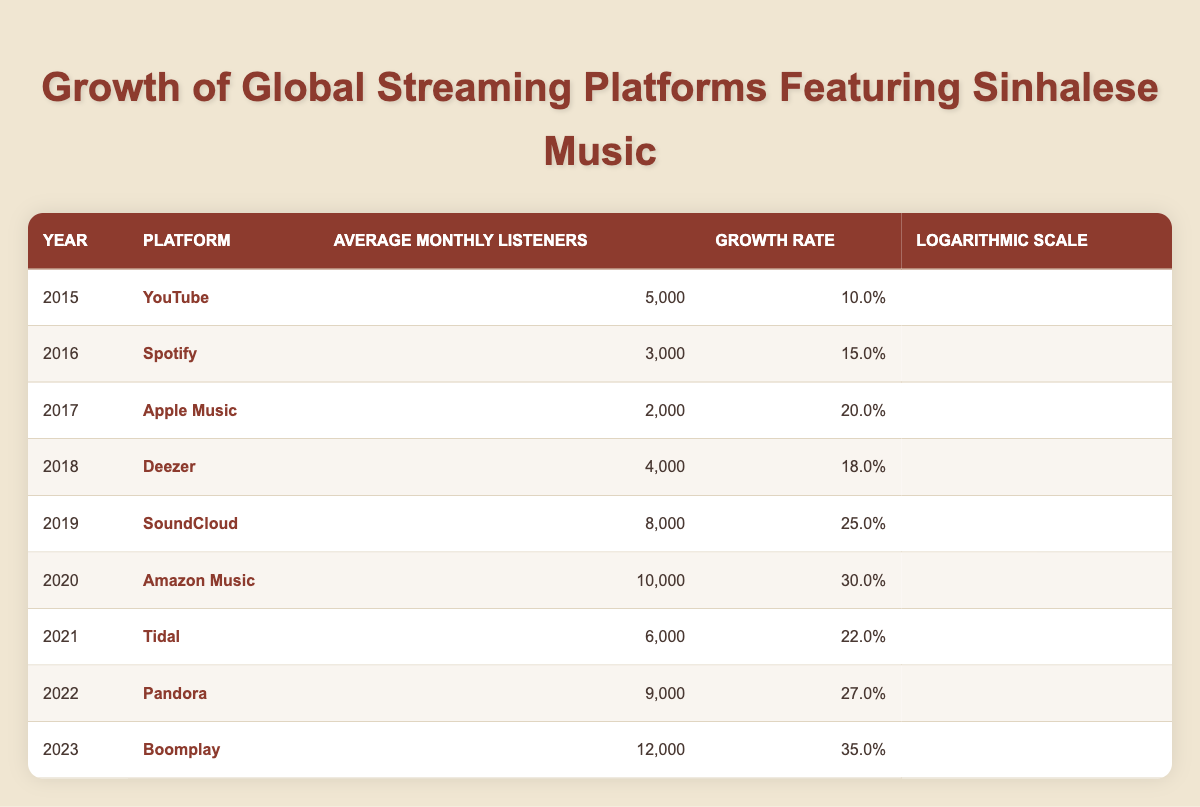What platform had the highest average monthly listeners in 2023? According to the table, Boomplay had the highest average monthly listeners in 2023, with 12,000 listeners.
Answer: Boomplay What was the growth rate of SoundCloud in 2019? The table indicates that the growth rate for SoundCloud in 2019 was 25.0%.
Answer: 25.0 Which platform saw a decline in average monthly listeners from 2015 to 2016? By comparing the average monthly listeners, there was a decline from YouTube (5,000) in 2015 to Spotify (3,000) in 2016, making it clear that there was a decline.
Answer: Yes What is the average growth rate of platforms listed from 2015 to 2023? Summing the growth rates from 2015 (10.0), 2016 (15.0), 2017 (20.0), 2018 (18.0), 2019 (25.0), 2020 (30.0), 2021 (22.0), 2022 (27.0), and 2023 (35.0) gives a total of 207.0. Since there are 9 platforms, the average growth rate is 207.0/9 = 23.0%.
Answer: 23.0 Which year showed the most significant growth rate increase compared to the previous year? To determine the most significant increase, examine each year: from 2022 to 2023, the growth rate increased from 27.0% to 35.0%, which is an 8.0% increase. Comparing other years reveals that this is indeed the highest increase.
Answer: 2022 to 2023 